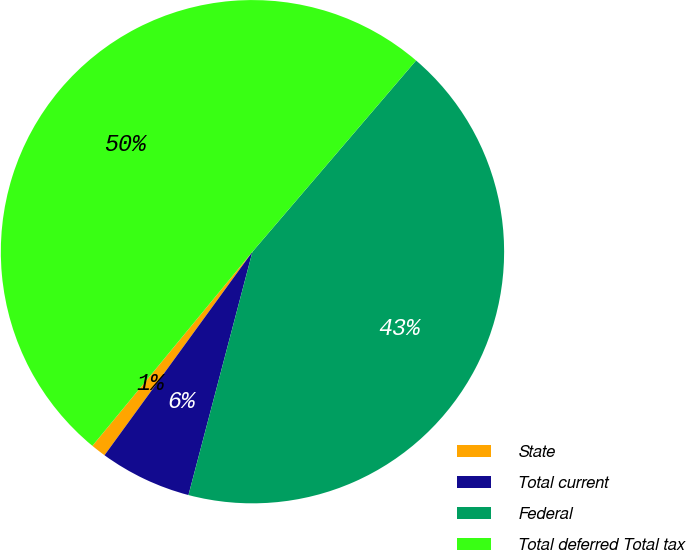Convert chart to OTSL. <chart><loc_0><loc_0><loc_500><loc_500><pie_chart><fcel>State<fcel>Total current<fcel>Federal<fcel>Total deferred Total tax<nl><fcel>0.97%<fcel>5.91%<fcel>42.83%<fcel>50.29%<nl></chart> 